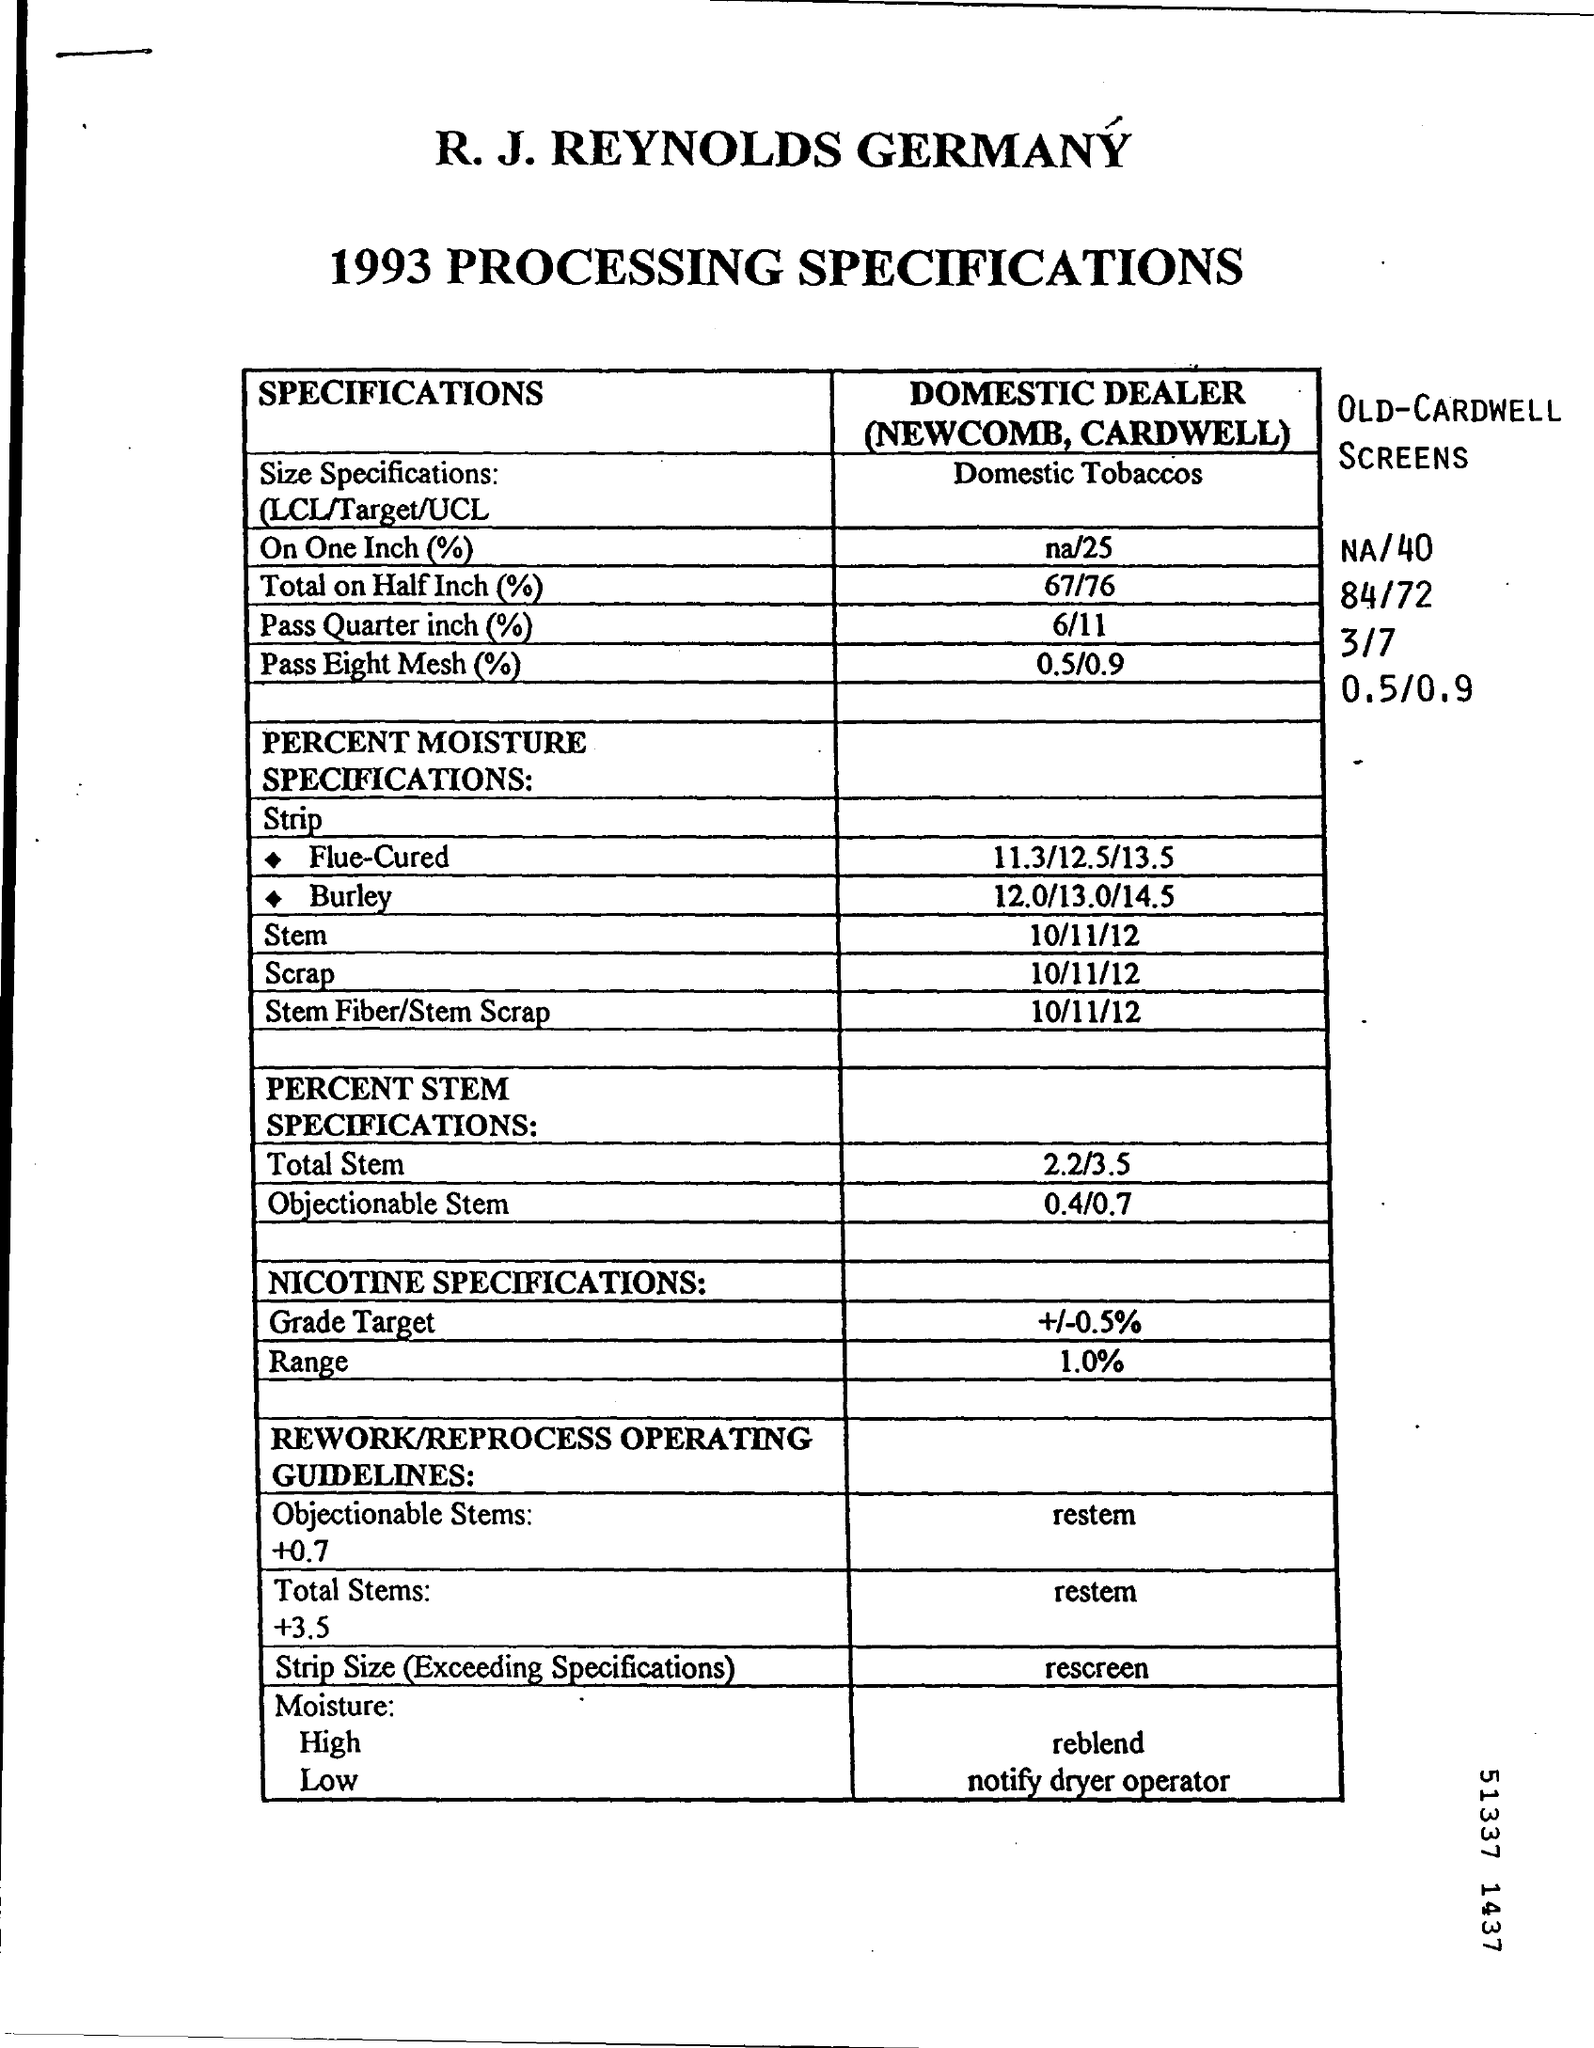What is the Scrap date mentioned in the Cover Sheet ?
Provide a succinct answer. 10/11/12. 